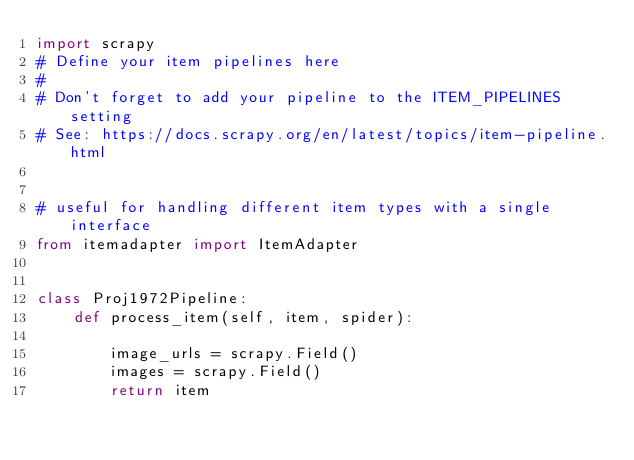<code> <loc_0><loc_0><loc_500><loc_500><_Python_>import scrapy
# Define your item pipelines here
#
# Don't forget to add your pipeline to the ITEM_PIPELINES setting
# See: https://docs.scrapy.org/en/latest/topics/item-pipeline.html


# useful for handling different item types with a single interface
from itemadapter import ItemAdapter


class Proj1972Pipeline:
    def process_item(self, item, spider):

        image_urls = scrapy.Field()
        images = scrapy.Field()
        return item</code> 